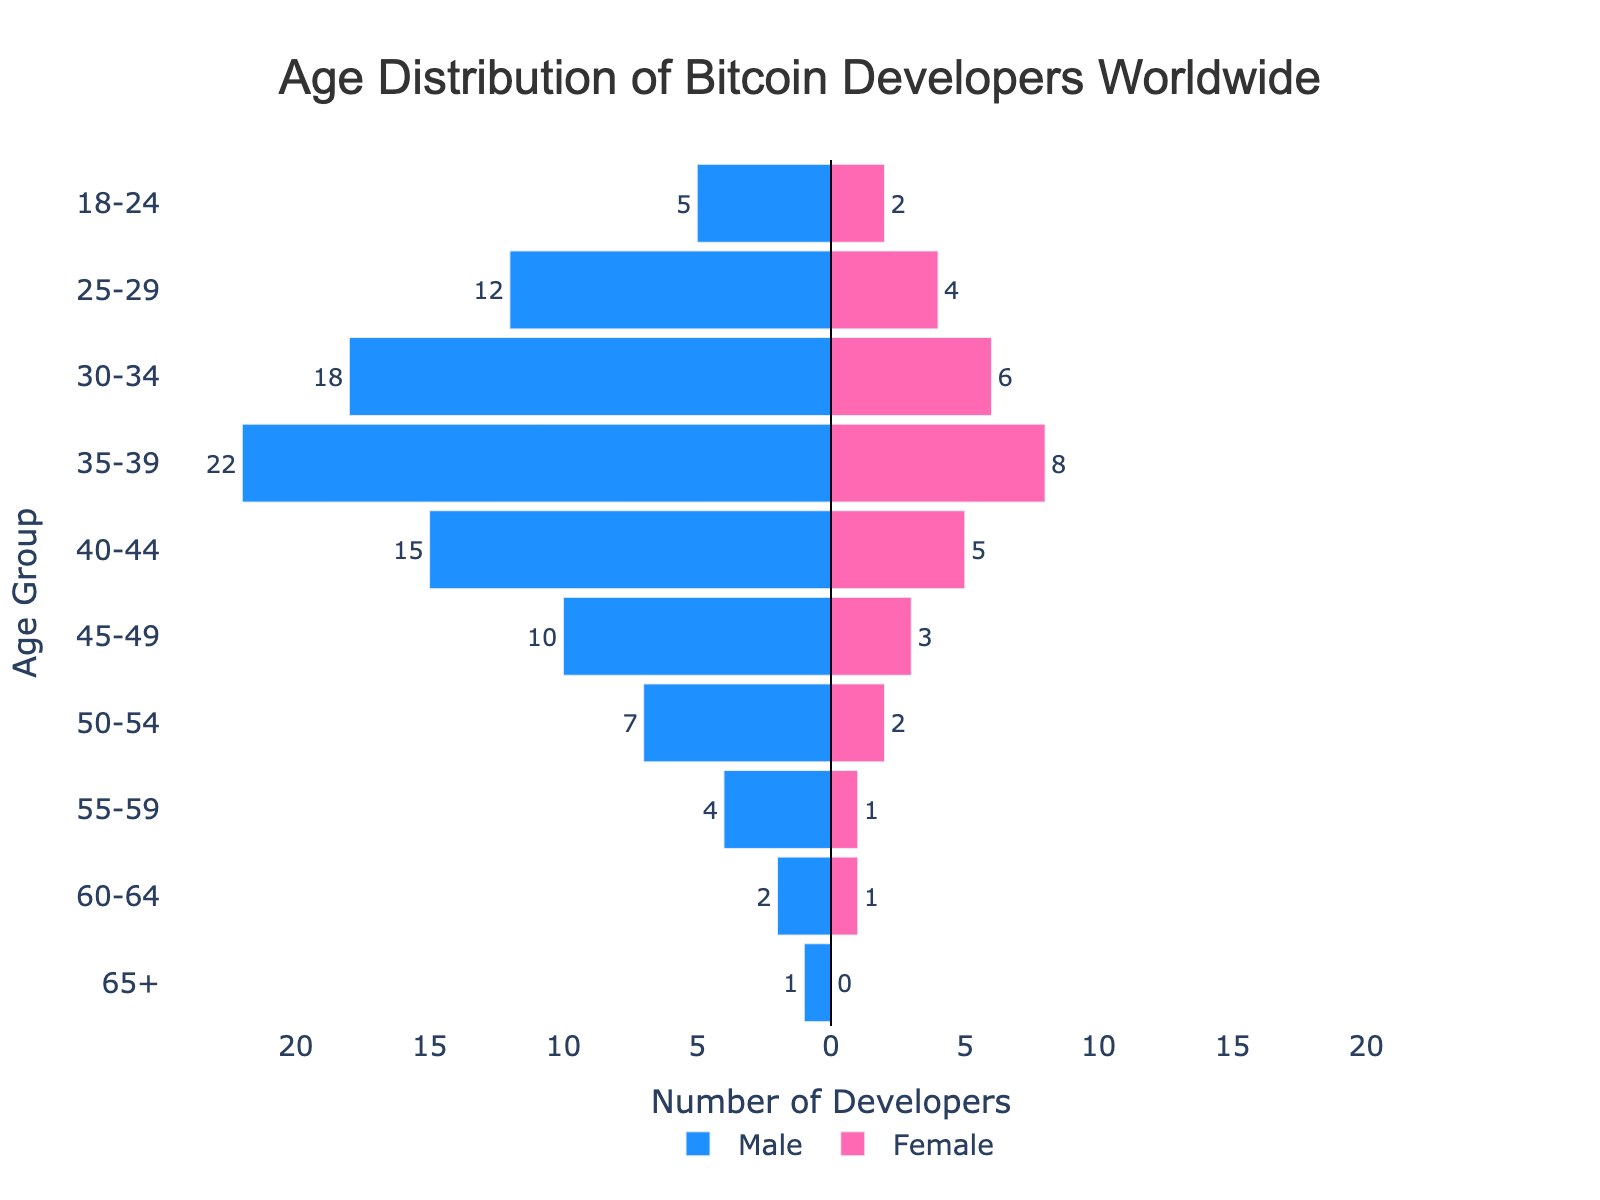What does the title of the figure indicate? The title of the figure specifies the subject of the plot, which is the age distribution of Bitcoin developers worldwide.
Answer: Age Distribution of Bitcoin Developers Worldwide Which age group has the highest number of male developers? To determine the age group with the highest number of male developers, look at the longest bar on the left side (negative values). The age group 35-39 has the furthest extending bar.
Answer: 35-39 How many total male developers are there in the age group 30-39? Sum the values from the age groups 30-34 (18 males) and 35-39 (22 males). Total is 18 + 22.
Answer: 40 In the age group 40-44, how many more male developers are there than female developers? Subtract the number of female developers from male developers in the 40-44 age group: 15 (males) - 5 (females) = 10.
Answer: 10 What is the total number of female developers aged 50+? Sum the number of female developers from the age groups 50-54 (2), 55-59 (1), 60-64 (1), and 65+ (0). Total is 2 + 1 + 1 + 0.
Answer: 4 Which age group has an equal number of male and female developers? Compare the values for each age group. The age group 60-64 has 2 male developers and 2 female developers.
Answer: 60-64 What is the sum of male and female developers in the age group 25-29? Add the number of male (12) and female (4) developers in the age group 25-29. Total is 12 + 4.
Answer: 16 Is there any age group with no developers listed? Check each age group to see if the total number of developers (both male and female) is zero. No age group has a zero total.
Answer: No Compare the developers in the age groups 45-49 and 50-54. Which group has more developers? Add the male and female developers in 45-49 (10 + 3 = 13) and 50-54 (7 + 2 = 9). Age group 45-49 has more developers.
Answer: 45-49 